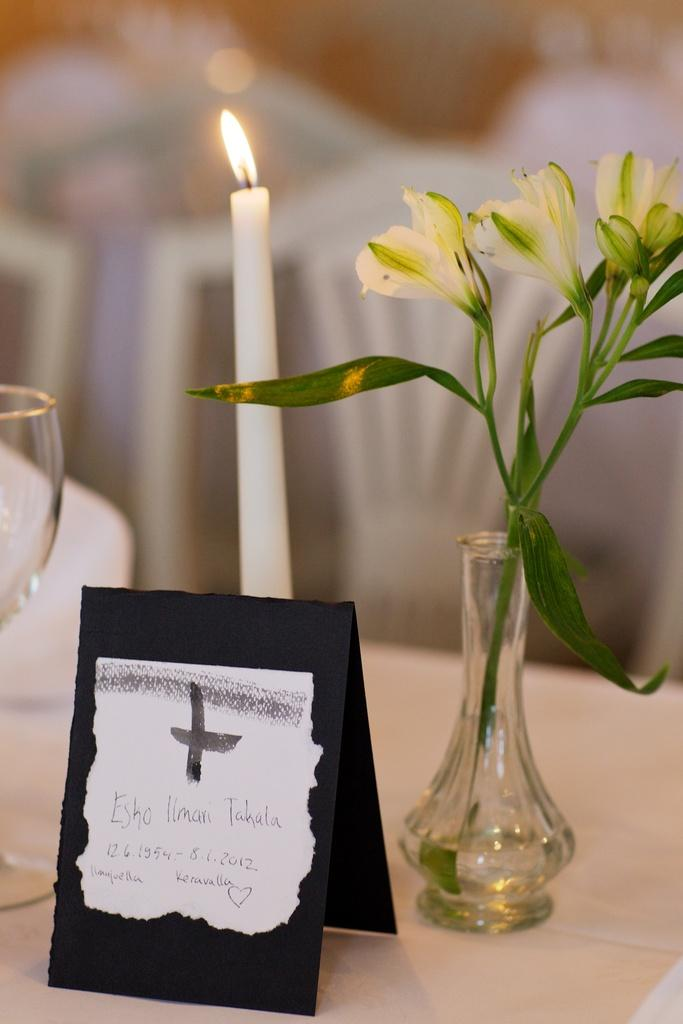What type of candle is in the image? There is a white candle in the image. What is the flower placed in? The flower is in a glass pot in the image. What is the glass used for? The glass is in the image, but its purpose is not specified. What can be found on the label in the image? The label is in the image, but its content is not specified. Where are all these objects located? All of these objects are placed on a table. Can you tell me how many times the lawyer has bitten the candle in the image? There is no lawyer or biting of the candle present in the image; it only features a white candle, a flower in a glass pot, a glass, and a label on a table. 